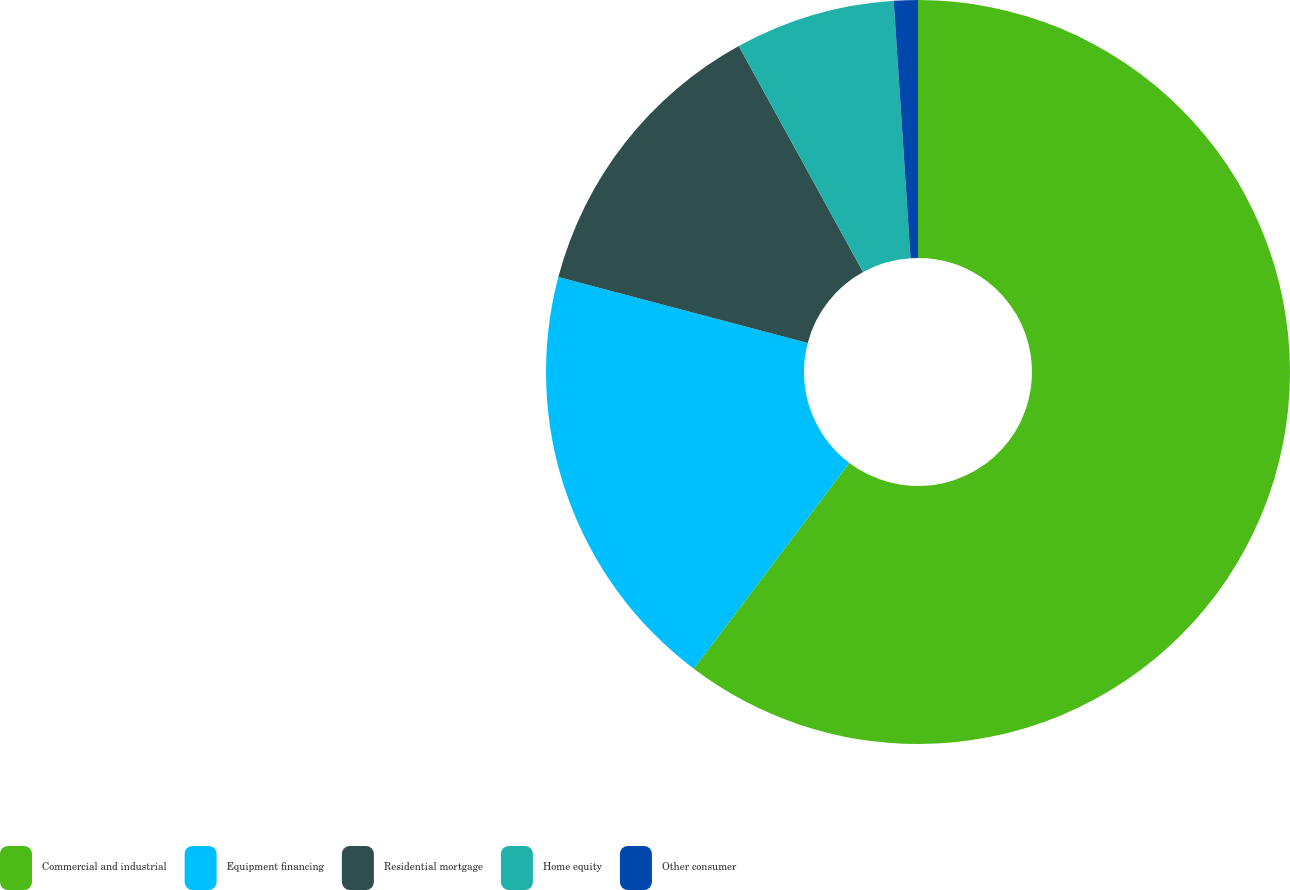Convert chart to OTSL. <chart><loc_0><loc_0><loc_500><loc_500><pie_chart><fcel>Commercial and industrial<fcel>Equipment financing<fcel>Residential mortgage<fcel>Home equity<fcel>Other consumer<nl><fcel>60.29%<fcel>18.81%<fcel>12.89%<fcel>6.96%<fcel>1.04%<nl></chart> 